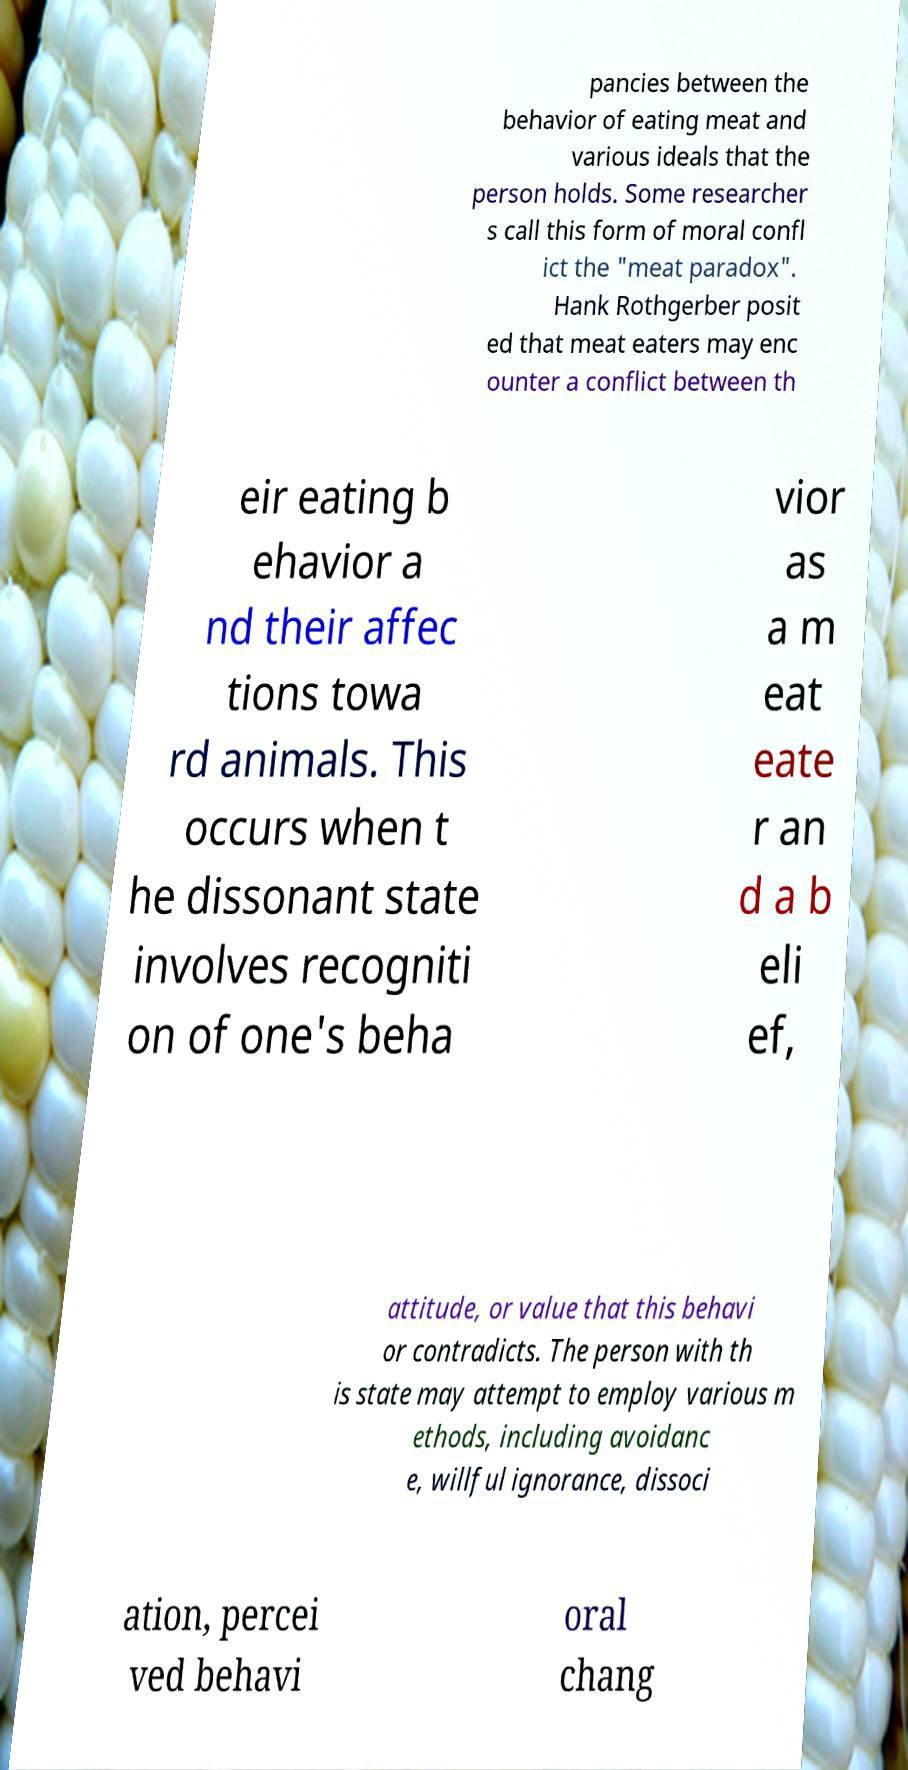For documentation purposes, I need the text within this image transcribed. Could you provide that? pancies between the behavior of eating meat and various ideals that the person holds. Some researcher s call this form of moral confl ict the "meat paradox". Hank Rothgerber posit ed that meat eaters may enc ounter a conflict between th eir eating b ehavior a nd their affec tions towa rd animals. This occurs when t he dissonant state involves recogniti on of one's beha vior as a m eat eate r an d a b eli ef, attitude, or value that this behavi or contradicts. The person with th is state may attempt to employ various m ethods, including avoidanc e, willful ignorance, dissoci ation, percei ved behavi oral chang 